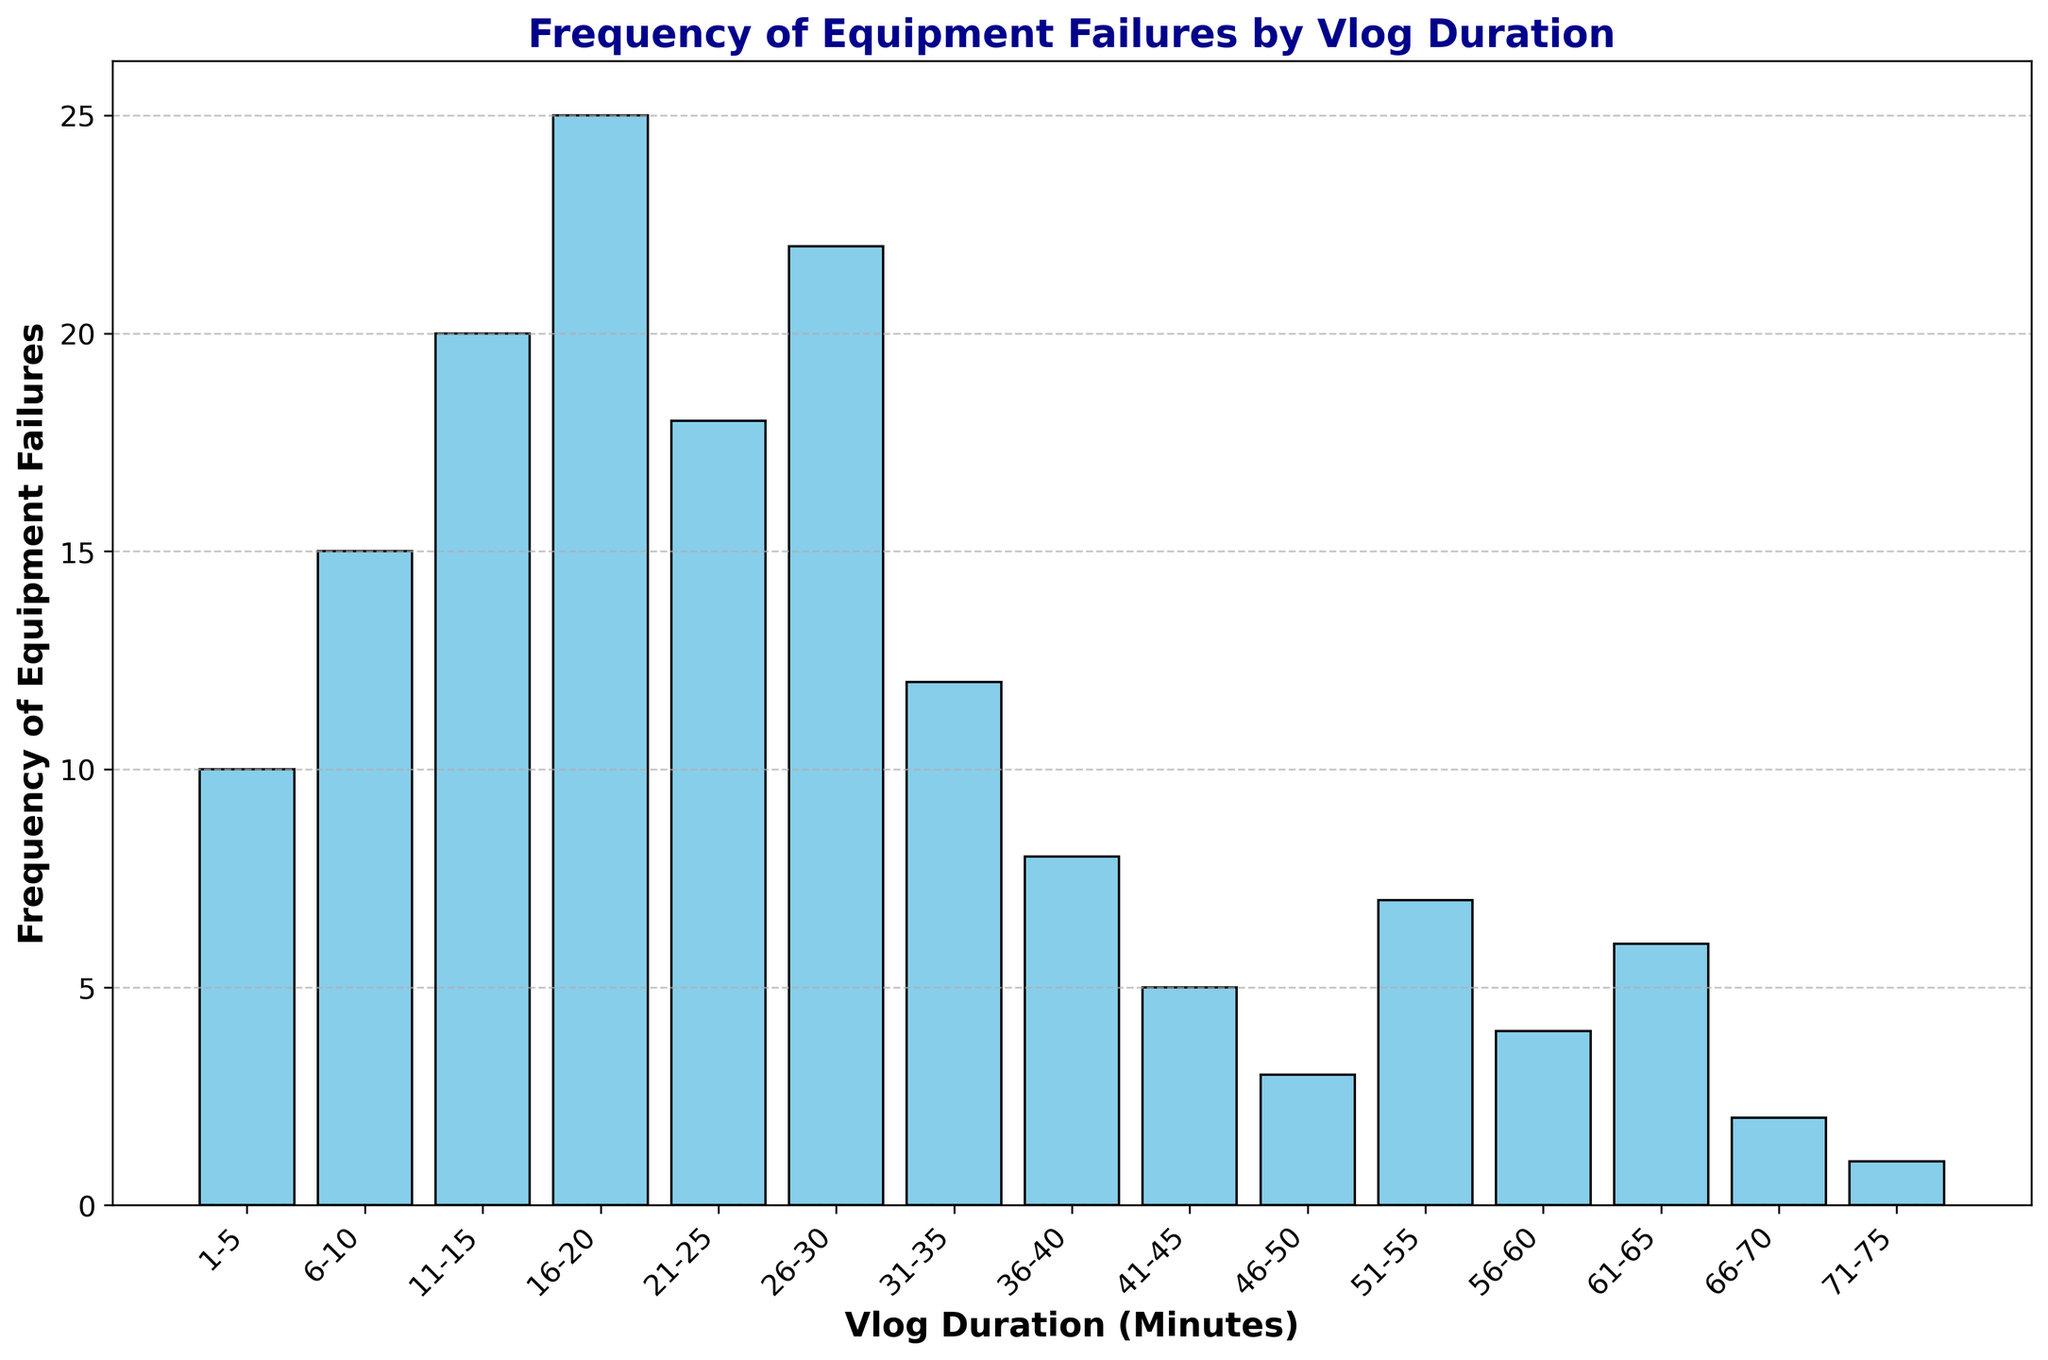Which vlog duration has the highest frequency of equipment failures? From the bar chart, identify the tallest bar. The vlog duration 16-20 minutes has the highest bar with 25 failures.
Answer: 16-20 minutes How does the frequency of failures for 31-35 minute vlogs compare to 1-5 minute vlogs? Compare the height of the bars for 31-35 minutes and 1-5 minutes. The bar for 1-5 minutes shows 10 failures while the bar for 31-35 minutes shows 12 failures. Therefore, 31-35 minute vlogs have 2 more failures than 1-5 minute vlogs.
Answer: 2 more failures What is the total frequency of equipment failures for vlogs longer than 50 minutes? Sum the frequencies of all vlog durations over 50 minutes: 51-55 (7), 56-60 (4), 61-65 (6), 66-70 (2), and 71-75 (1). This gives 7 + 4 + 6 + 2 + 1 = 20.
Answer: 20 Is the frequency of equipment failures for 26-30 minute vlogs greater than or less than the sum of failures for 41-45 and 46-50 minute vlogs? Compare the frequency for 26-30 minute vlogs (22) to the sum of 41-45 (5) and 46-50 minute (3) vlogs. The sum is 5 + 3 = 8, which is less than 22.
Answer: Greater than For which vlog duration ranges is the frequency of equipment failures above 20? Identify the bars whose height is greater than 20. These bars correspond to 16-20 (25) and 26-30 (22) minute vlogs.
Answer: 16-20 and 26-30 minutes What is the difference in frequency of equipment failures between the durations 21-25 minutes and 36-40 minutes? Subtract the frequency of equipment failures for 36-40 minutes (8) from that of 21-25 minutes (18). The difference is 18 - 8 = 10.
Answer: 10 Which vlog durations have a frequency of equipment failures less than 5? Identify the bars with heights less than 5. These correspond to 46-50 (3), 66-70 (2), and 71-75 (1) minute vlogs.
Answer: 46-50, 66-70, and 71-75 minutes What is the average frequency of equipment failures for vlog durations in the range of 1-10 minutes? Calculate the average frequency for 1-5 (10) and 6-10 (15) minutes. The average is (10 + 15) / 2 = 12.5.
Answer: 12.5 How does the frequency of equipment failures trend as the vlog duration increases from 1-75 minutes? Observe the bars from left to right. The frequency generally increases until 16-20 minutes, spikes again at 26-30 minutes, then generally decreases as the vlog duration increases further.
Answer: Increases first, spikes, then decreases 